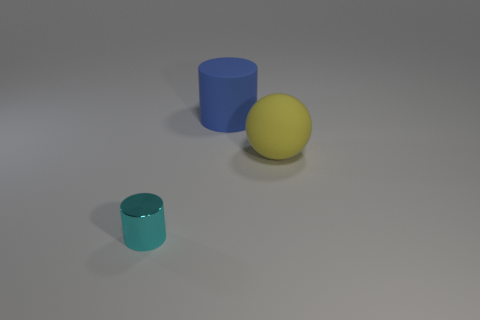Are there any yellow matte spheres? Yes, there is one yellow matte sphere in the image, centrally located and juxtaposed against two other geometric shapes. 